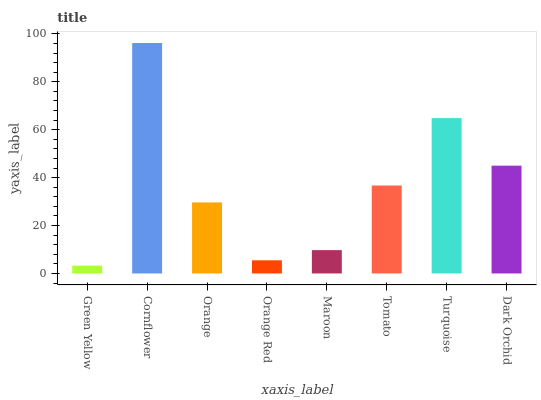Is Green Yellow the minimum?
Answer yes or no. Yes. Is Cornflower the maximum?
Answer yes or no. Yes. Is Orange the minimum?
Answer yes or no. No. Is Orange the maximum?
Answer yes or no. No. Is Cornflower greater than Orange?
Answer yes or no. Yes. Is Orange less than Cornflower?
Answer yes or no. Yes. Is Orange greater than Cornflower?
Answer yes or no. No. Is Cornflower less than Orange?
Answer yes or no. No. Is Tomato the high median?
Answer yes or no. Yes. Is Orange the low median?
Answer yes or no. Yes. Is Orange Red the high median?
Answer yes or no. No. Is Green Yellow the low median?
Answer yes or no. No. 